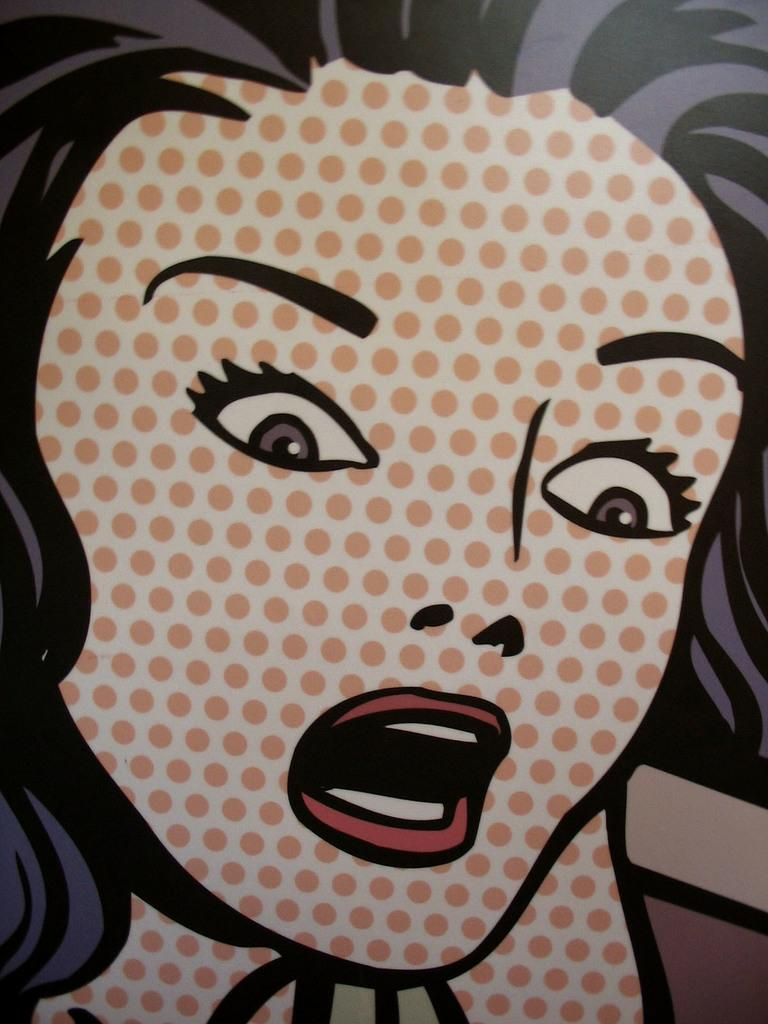What is present in the image that features a woman? There is a poster in the image that features a woman. What part of the woman's appearance is visible on the poster? The woman's hair is visible on the poster. What type of joke is the woman telling at the airport in the image? There is no airport or joke present in the image; it only features a poster with a woman and her visible hair. 